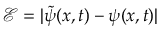Convert formula to latex. <formula><loc_0><loc_0><loc_500><loc_500>\mathcal { E } = | \tilde { \psi } ( x , t ) - \psi ( x , t ) |</formula> 